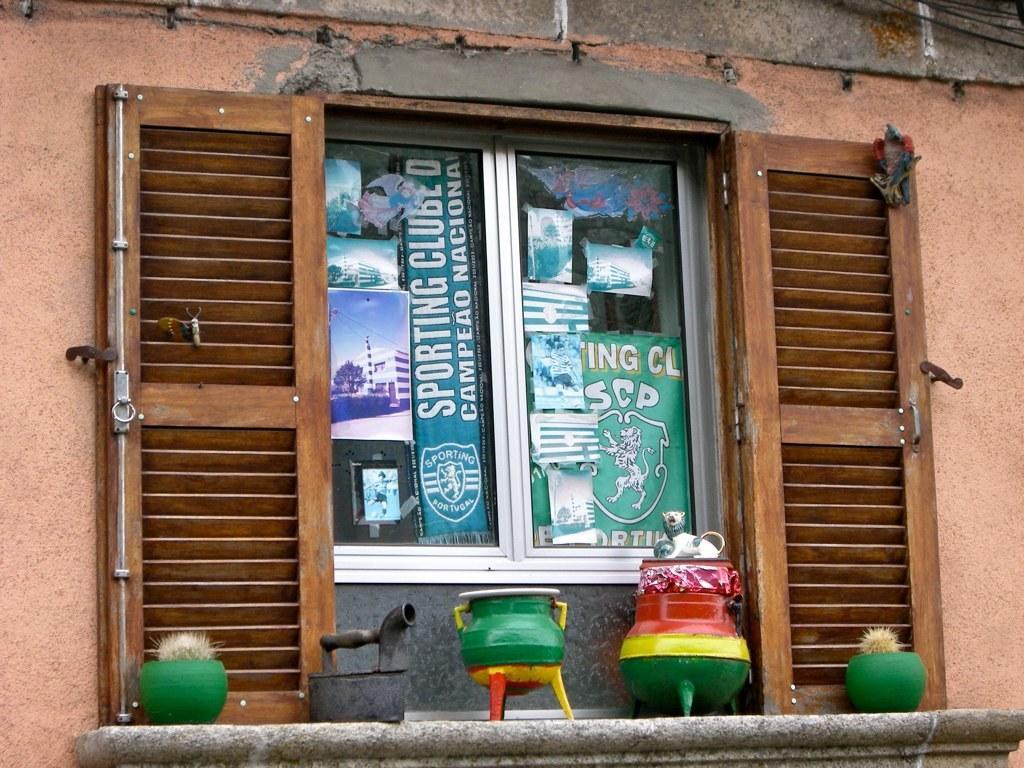In one or two sentences, can you explain what this image depicts? In this picture we can see a few colorful objects on the wall at the bottom of the picture. We can see some text, logo and the images of some buildings on the glass objects. There are wooden objects visible on a wall. 